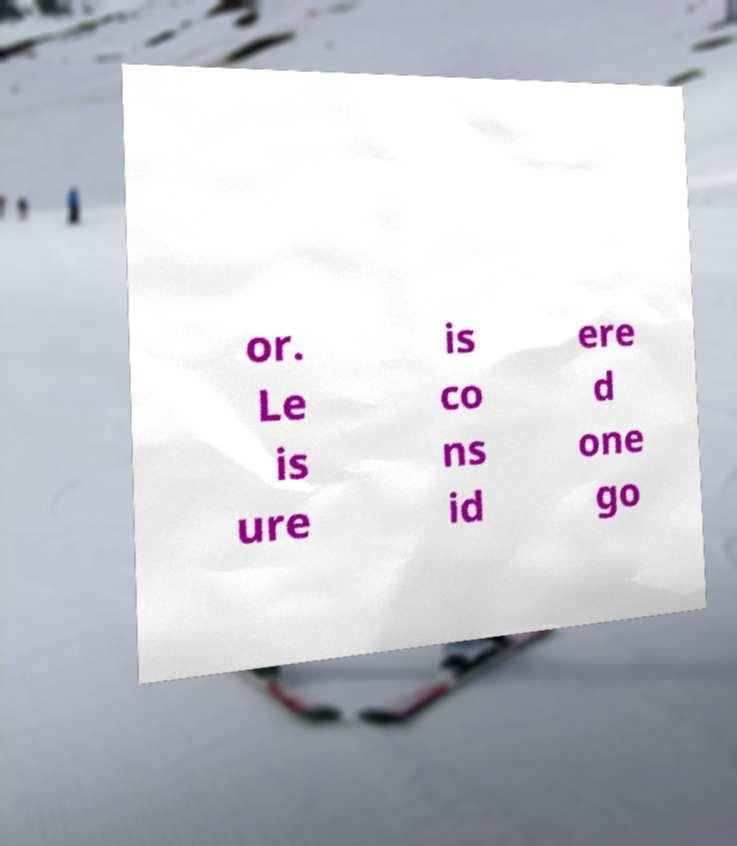I need the written content from this picture converted into text. Can you do that? or. Le is ure is co ns id ere d one go 